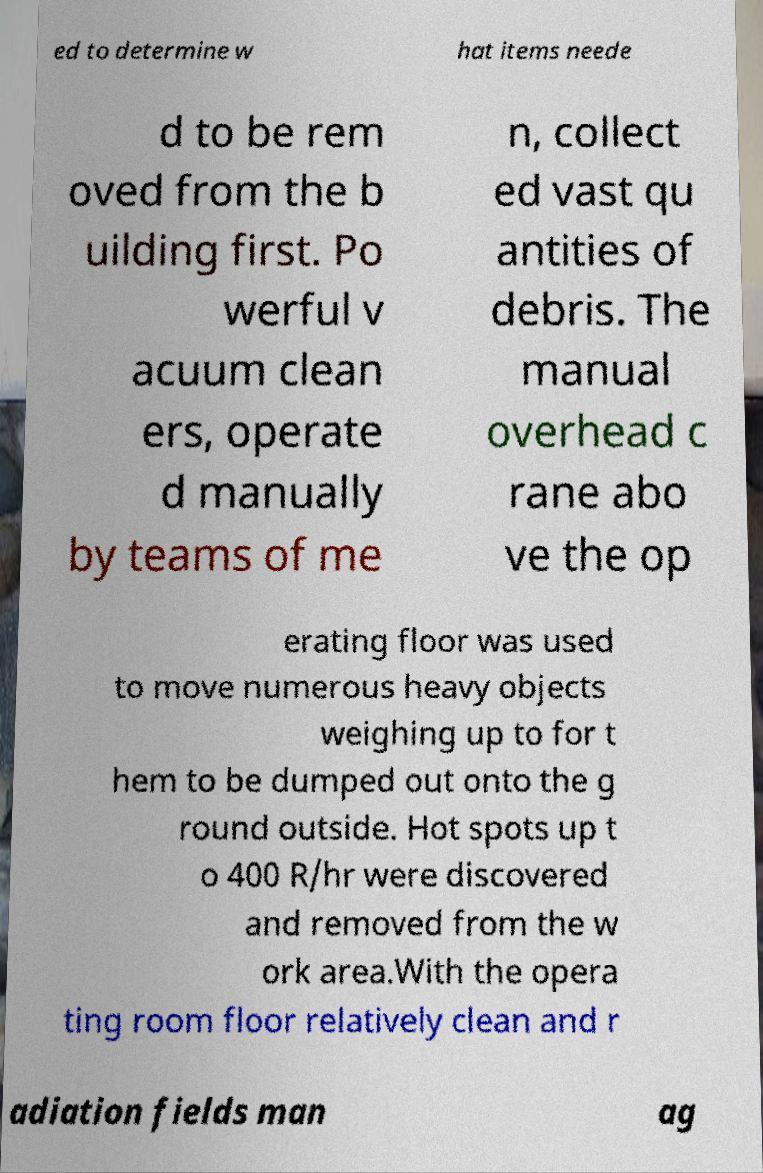Please identify and transcribe the text found in this image. ed to determine w hat items neede d to be rem oved from the b uilding first. Po werful v acuum clean ers, operate d manually by teams of me n, collect ed vast qu antities of debris. The manual overhead c rane abo ve the op erating floor was used to move numerous heavy objects weighing up to for t hem to be dumped out onto the g round outside. Hot spots up t o 400 R/hr were discovered and removed from the w ork area.With the opera ting room floor relatively clean and r adiation fields man ag 